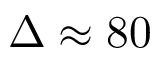Convert formula to latex. <formula><loc_0><loc_0><loc_500><loc_500>\Delta \approx 8 0</formula> 